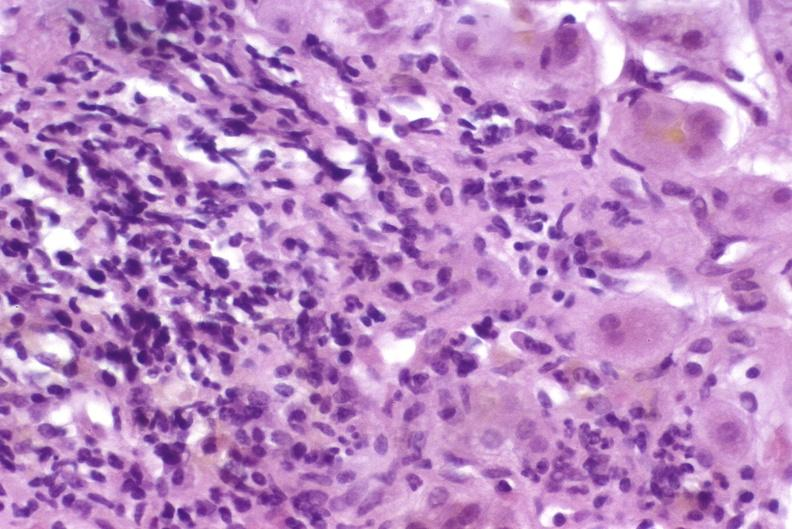what is present?
Answer the question using a single word or phrase. Hepatobiliary 